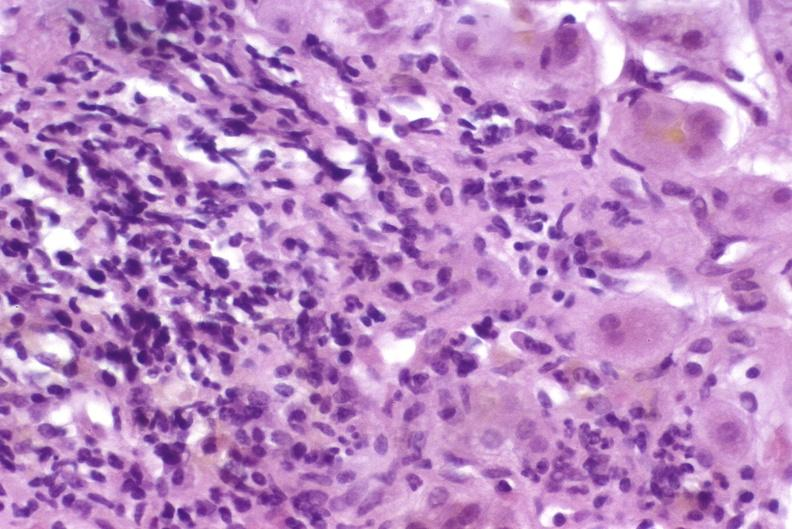what is present?
Answer the question using a single word or phrase. Hepatobiliary 